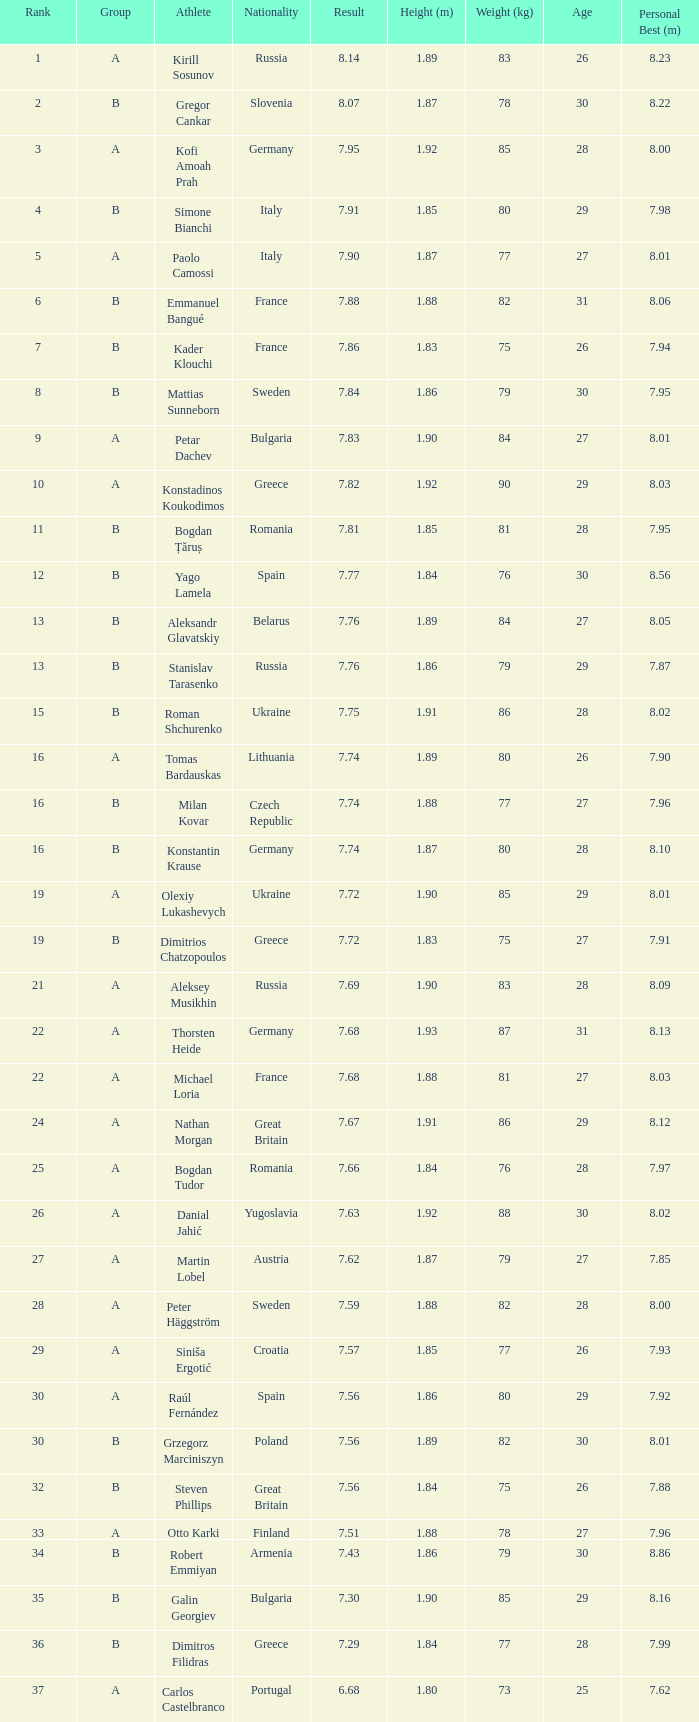In group b, who is the british athlete with a rank higher than 15 and a result below 7.68? Steven Phillips. 